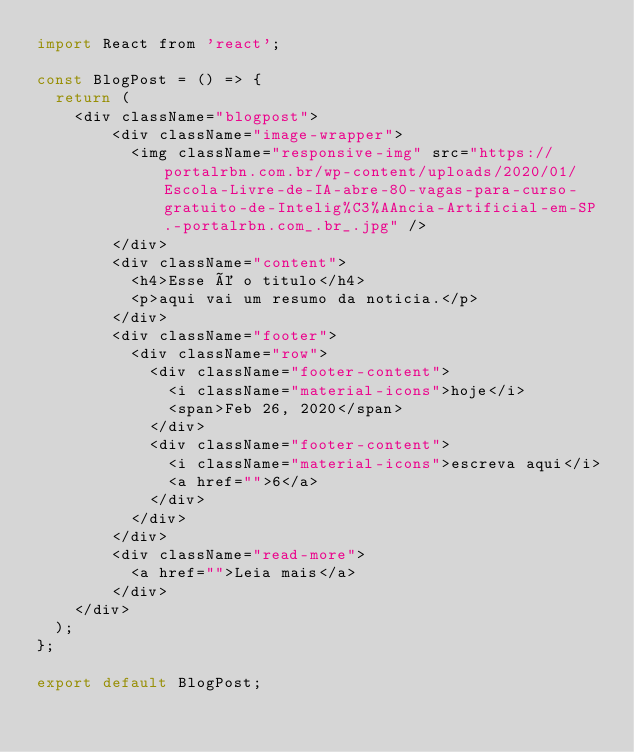Convert code to text. <code><loc_0><loc_0><loc_500><loc_500><_JavaScript_>import React from 'react';

const BlogPost = () => {
  return (
    <div className="blogpost">
        <div className="image-wrapper">
          <img className="responsive-img" src="https://portalrbn.com.br/wp-content/uploads/2020/01/Escola-Livre-de-IA-abre-80-vagas-para-curso-gratuito-de-Intelig%C3%AAncia-Artificial-em-SP.-portalrbn.com_.br_.jpg" />
        </div>
        <div className="content">
          <h4>Esse é o titulo</h4>
          <p>aqui vai um resumo da noticia.</p>
        </div>
        <div className="footer">
          <div className="row">
            <div className="footer-content">
              <i className="material-icons">hoje</i>
              <span>Feb 26, 2020</span>
            </div>
            <div className="footer-content">
              <i className="material-icons">escreva aqui</i>
              <a href="">6</a>
            </div>
          </div>
        </div>
        <div className="read-more">
          <a href="">Leia mais</a>
        </div>
    </div>
  );
};

export default BlogPost;
</code> 